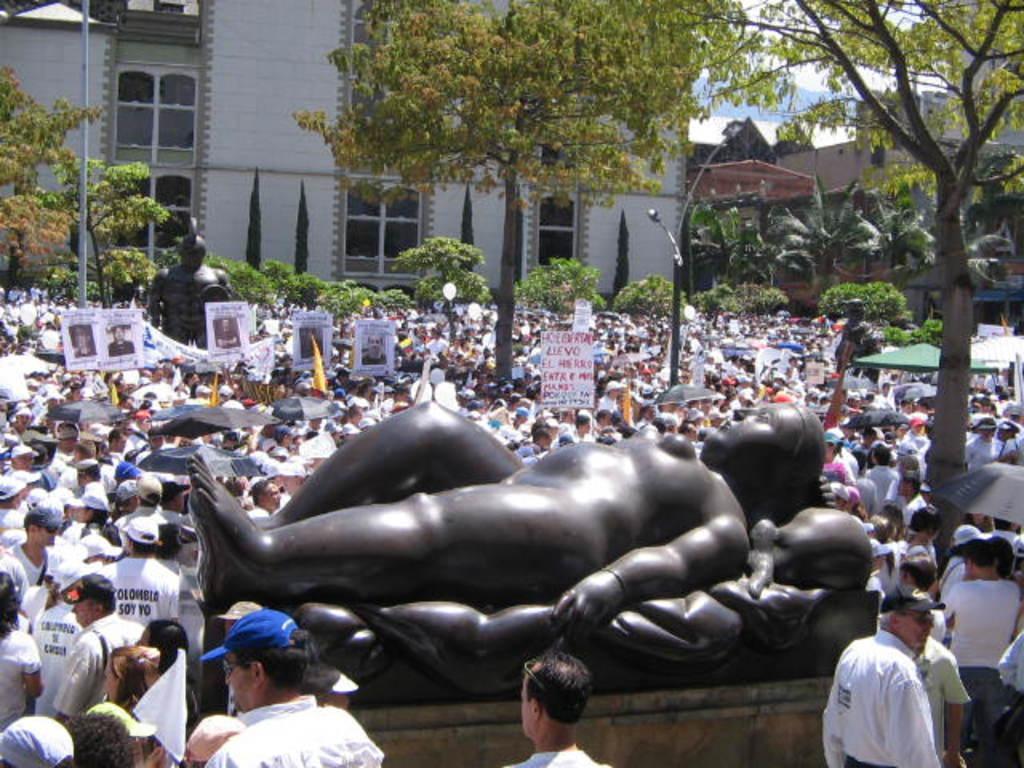Can you describe this image briefly? In the image on the pedestal there is a statue. And there are many people in the image with caps on their heads and also there are holding posters in their hands. And also there are few people holding umbrellas. There are poles with street lights, statues, tents, trees and buildings with walls and glass windows.  